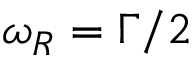Convert formula to latex. <formula><loc_0><loc_0><loc_500><loc_500>\omega _ { R } = \Gamma / 2</formula> 